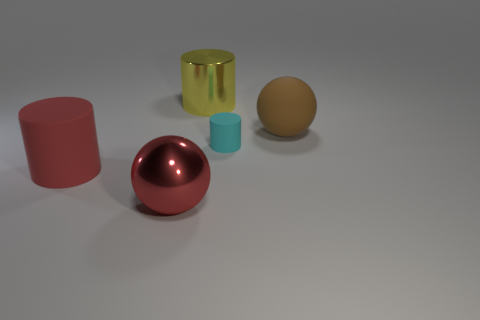Is the color of the large rubber cylinder the same as the big metal sphere?
Your answer should be very brief. Yes. How many large matte objects are the same color as the large rubber cylinder?
Make the answer very short. 0. What size is the matte cylinder that is to the right of the big cylinder that is to the left of the red shiny sphere?
Ensure brevity in your answer.  Small. What shape is the large red rubber thing?
Your answer should be compact. Cylinder. There is a big ball that is behind the large red matte thing; what material is it?
Provide a succinct answer. Rubber. What color is the big metallic thing behind the big red object that is in front of the cylinder in front of the small cyan cylinder?
Make the answer very short. Yellow. There is a shiny object that is the same size as the metal ball; what color is it?
Your answer should be compact. Yellow. How many matte objects are either big balls or cyan objects?
Keep it short and to the point. 2. There is a sphere that is made of the same material as the yellow cylinder; what is its color?
Provide a succinct answer. Red. What material is the large cylinder that is behind the big matte object right of the shiny sphere?
Ensure brevity in your answer.  Metal. 